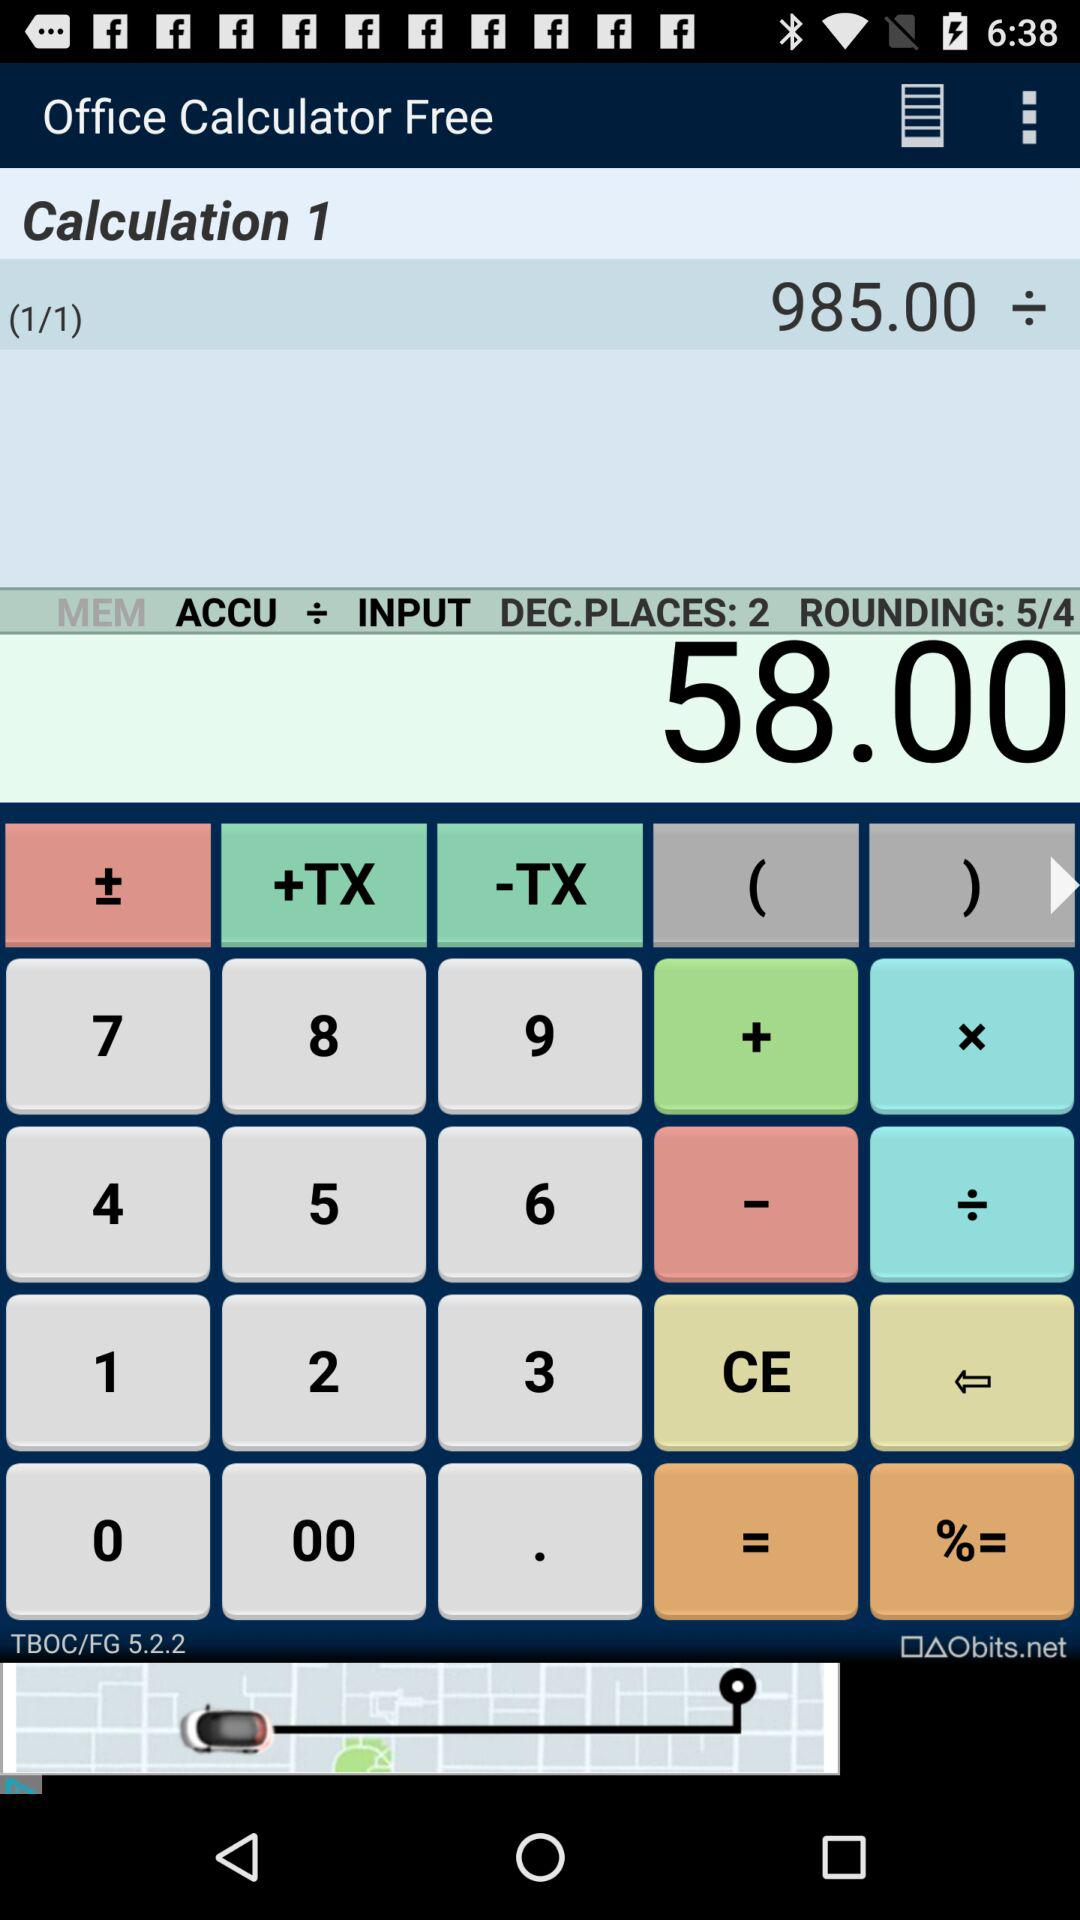What is the output value?
When the provided information is insufficient, respond with <no answer>. <no answer> 